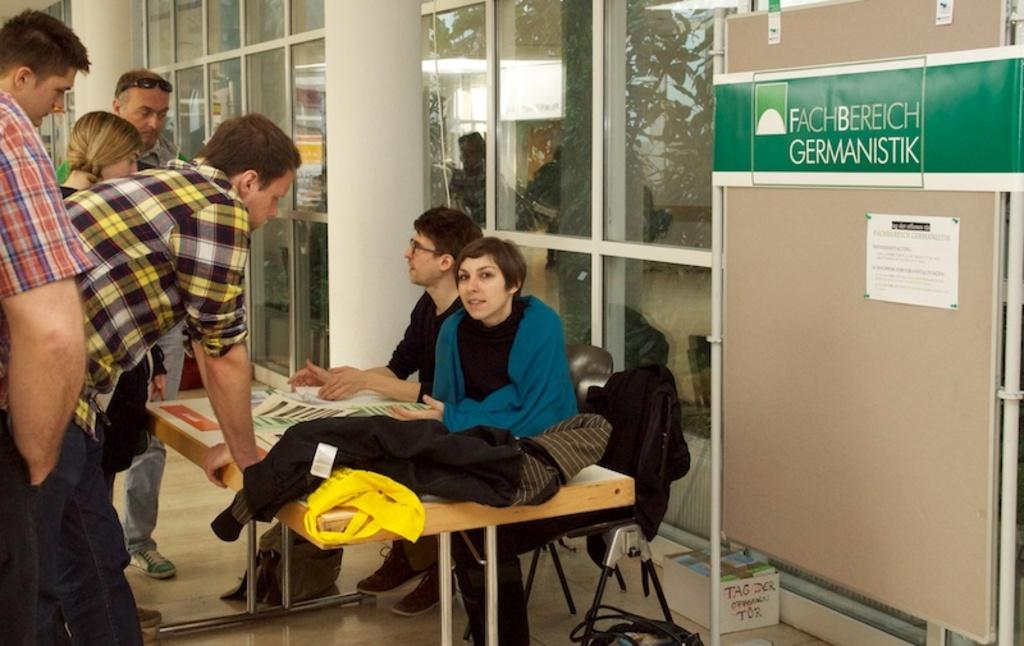How many people are seated in the image? There are two people seated on a chair in the image. What are the seated individuals doing? The seated individuals are being spoken to by people who are standing. What type of airplane can be seen flying over the field in the image? There is no airplane or field present in the image; it features two people seated on a chair and people standing and speaking to them. 